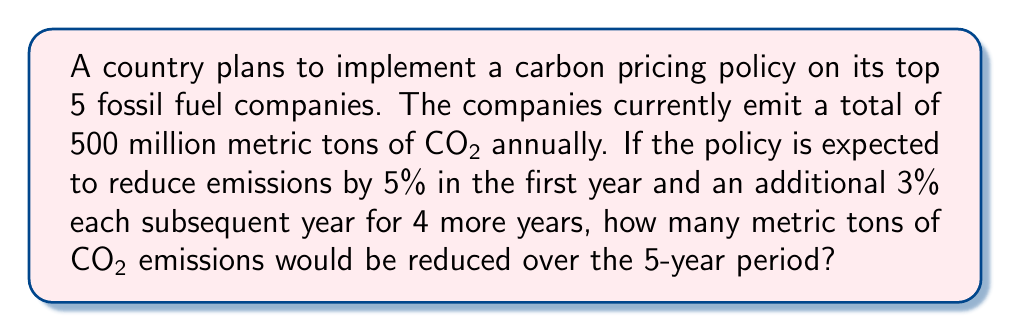Show me your answer to this math problem. Let's approach this step-by-step:

1) First, let's calculate the emissions reduction for each year:

   Year 1: $500,000,000 \times 0.05 = 25,000,000$ metric tons

   Year 2: $500,000,000 \times (0.05 + 0.03) = 500,000,000 \times 0.08 = 40,000,000$ metric tons

   Year 3: $500,000,000 \times (0.05 + 0.03 + 0.03) = 500,000,000 \times 0.11 = 55,000,000$ metric tons

   Year 4: $500,000,000 \times (0.05 + 0.03 + 0.03 + 0.03) = 500,000,000 \times 0.14 = 70,000,000$ metric tons

   Year 5: $500,000,000 \times (0.05 + 0.03 + 0.03 + 0.03 + 0.03) = 500,000,000 \times 0.17 = 85,000,000$ metric tons

2) Now, let's sum up the reductions from all 5 years:

   $$25,000,000 + 40,000,000 + 55,000,000 + 70,000,000 + 85,000,000 = 275,000,000$$

Therefore, over the 5-year period, the total reduction in CO2 emissions would be 275 million metric tons.
Answer: 275 million metric tons 